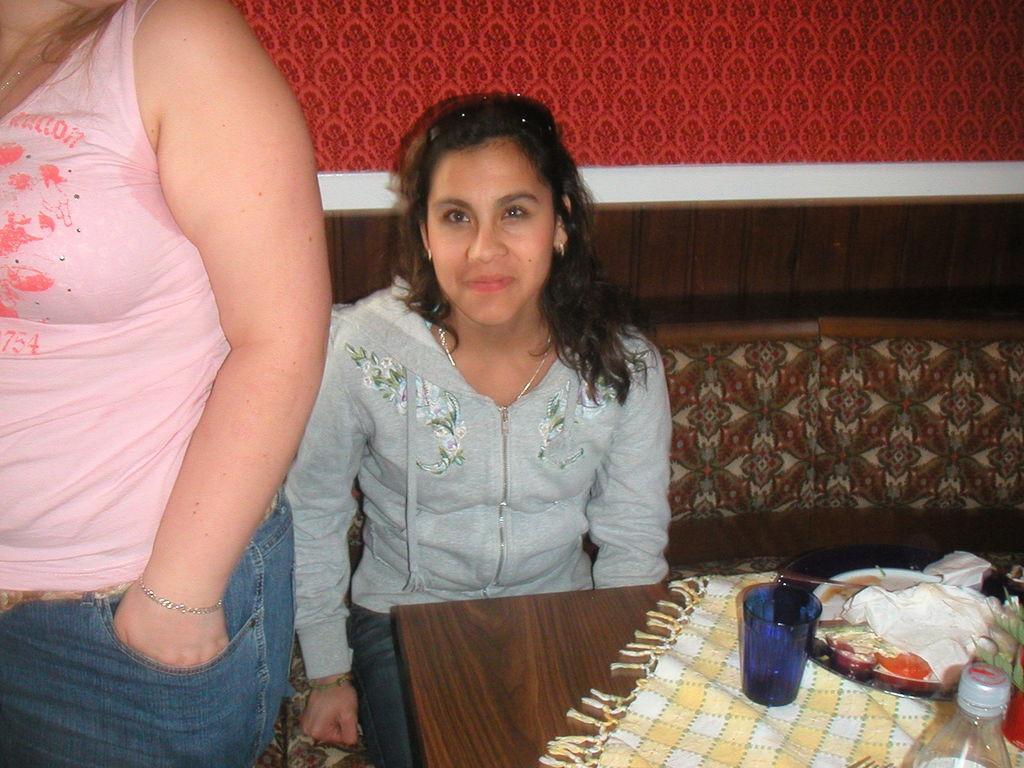Can you describe this image briefly? In this image there are two persons, One of the person is standing and another is sitting. There are few objects are placed on the table. 